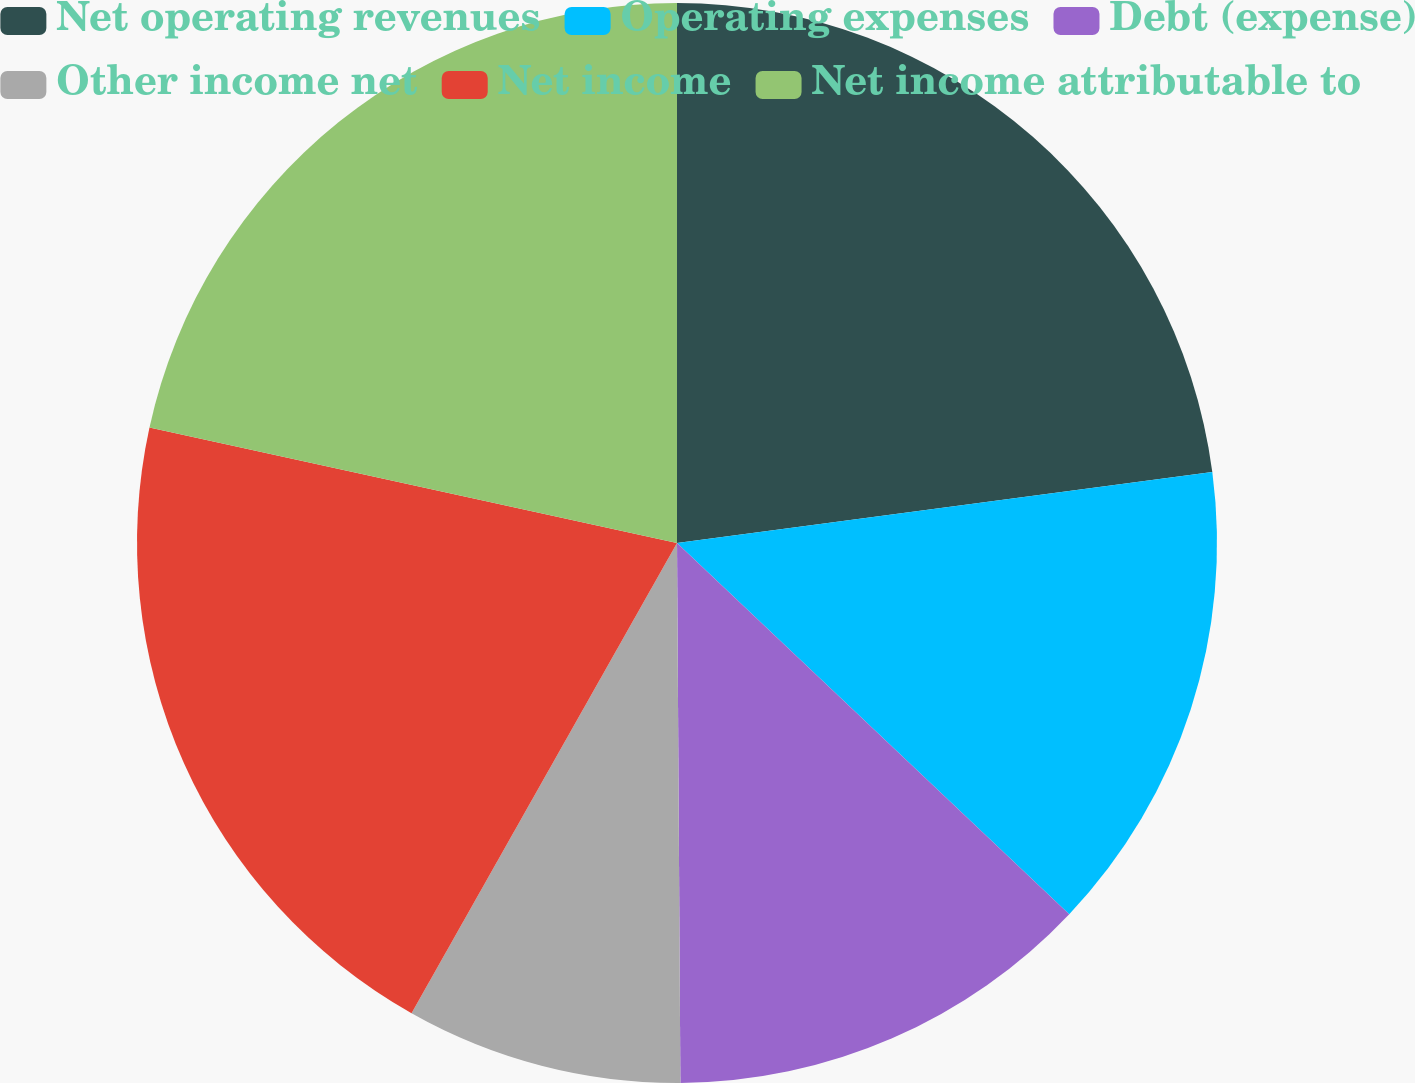Convert chart. <chart><loc_0><loc_0><loc_500><loc_500><pie_chart><fcel>Net operating revenues<fcel>Operating expenses<fcel>Debt (expense)<fcel>Other income net<fcel>Net income<fcel>Net income attributable to<nl><fcel>22.9%<fcel>14.16%<fcel>12.84%<fcel>8.28%<fcel>20.25%<fcel>21.57%<nl></chart> 